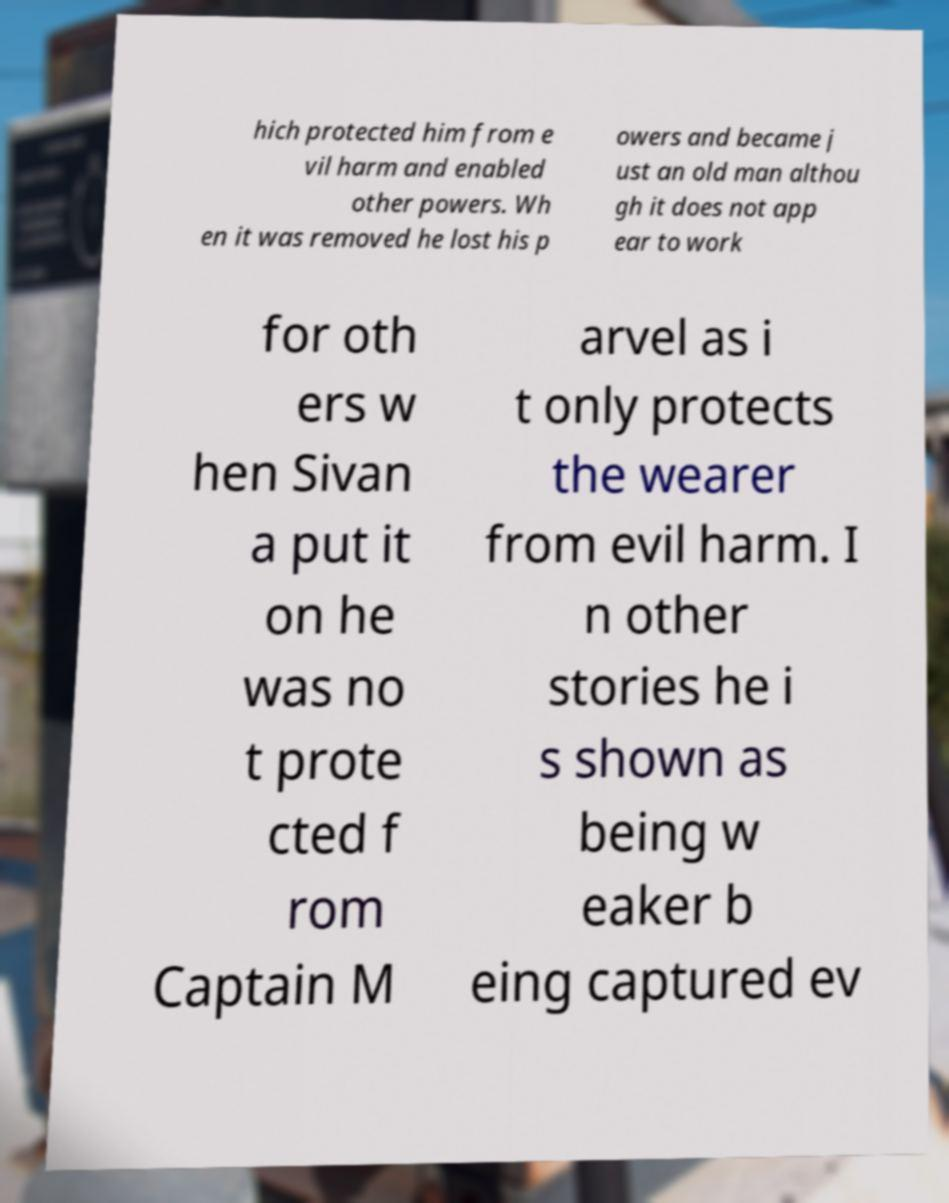I need the written content from this picture converted into text. Can you do that? hich protected him from e vil harm and enabled other powers. Wh en it was removed he lost his p owers and became j ust an old man althou gh it does not app ear to work for oth ers w hen Sivan a put it on he was no t prote cted f rom Captain M arvel as i t only protects the wearer from evil harm. I n other stories he i s shown as being w eaker b eing captured ev 